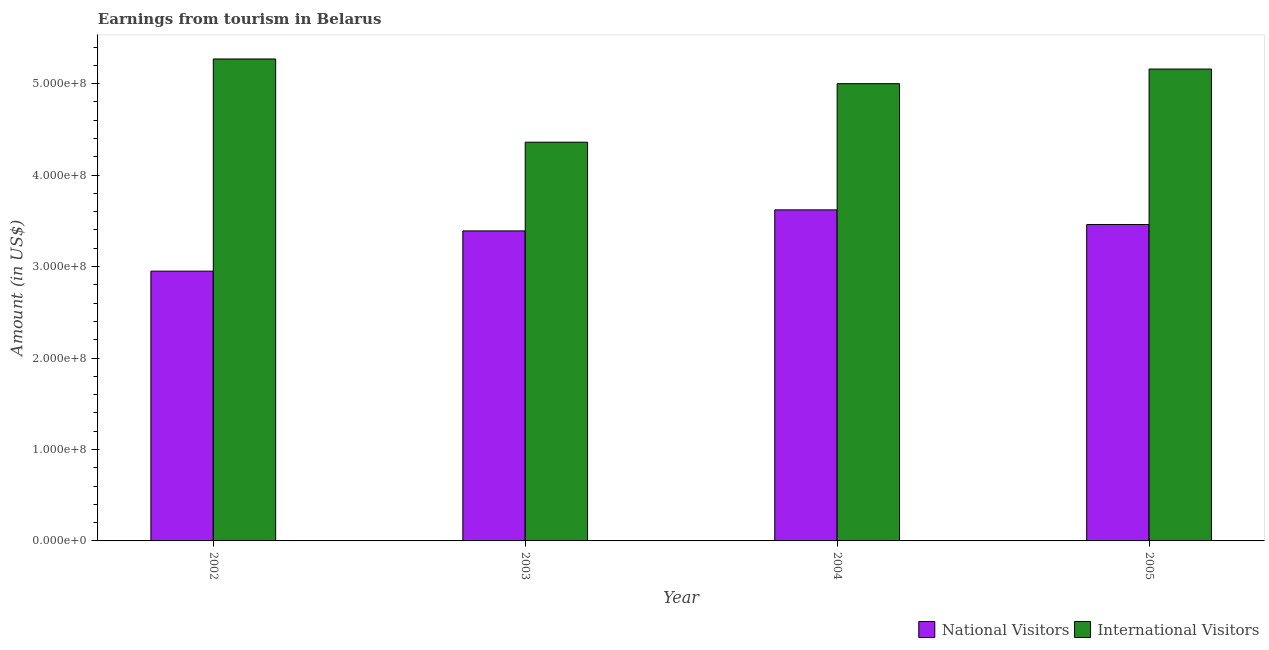Are the number of bars on each tick of the X-axis equal?
Your response must be concise. Yes. How many bars are there on the 4th tick from the left?
Ensure brevity in your answer.  2. What is the amount earned from international visitors in 2005?
Offer a very short reply. 5.16e+08. Across all years, what is the maximum amount earned from international visitors?
Ensure brevity in your answer.  5.27e+08. Across all years, what is the minimum amount earned from national visitors?
Make the answer very short. 2.95e+08. What is the total amount earned from international visitors in the graph?
Give a very brief answer. 1.98e+09. What is the difference between the amount earned from international visitors in 2002 and that in 2003?
Offer a terse response. 9.10e+07. What is the difference between the amount earned from national visitors in 2004 and the amount earned from international visitors in 2002?
Offer a terse response. 6.70e+07. What is the average amount earned from international visitors per year?
Keep it short and to the point. 4.95e+08. What is the ratio of the amount earned from international visitors in 2002 to that in 2004?
Offer a very short reply. 1.05. Is the difference between the amount earned from international visitors in 2002 and 2005 greater than the difference between the amount earned from national visitors in 2002 and 2005?
Make the answer very short. No. What is the difference between the highest and the second highest amount earned from national visitors?
Your answer should be very brief. 1.60e+07. What is the difference between the highest and the lowest amount earned from national visitors?
Offer a terse response. 6.70e+07. In how many years, is the amount earned from international visitors greater than the average amount earned from international visitors taken over all years?
Your answer should be very brief. 3. What does the 1st bar from the left in 2002 represents?
Give a very brief answer. National Visitors. What does the 1st bar from the right in 2002 represents?
Provide a succinct answer. International Visitors. How many years are there in the graph?
Ensure brevity in your answer.  4. Does the graph contain any zero values?
Give a very brief answer. No. Where does the legend appear in the graph?
Provide a short and direct response. Bottom right. What is the title of the graph?
Offer a very short reply. Earnings from tourism in Belarus. What is the label or title of the X-axis?
Make the answer very short. Year. What is the Amount (in US$) of National Visitors in 2002?
Offer a very short reply. 2.95e+08. What is the Amount (in US$) in International Visitors in 2002?
Keep it short and to the point. 5.27e+08. What is the Amount (in US$) in National Visitors in 2003?
Offer a terse response. 3.39e+08. What is the Amount (in US$) of International Visitors in 2003?
Give a very brief answer. 4.36e+08. What is the Amount (in US$) in National Visitors in 2004?
Offer a terse response. 3.62e+08. What is the Amount (in US$) in National Visitors in 2005?
Make the answer very short. 3.46e+08. What is the Amount (in US$) of International Visitors in 2005?
Make the answer very short. 5.16e+08. Across all years, what is the maximum Amount (in US$) of National Visitors?
Ensure brevity in your answer.  3.62e+08. Across all years, what is the maximum Amount (in US$) in International Visitors?
Your answer should be very brief. 5.27e+08. Across all years, what is the minimum Amount (in US$) of National Visitors?
Your answer should be compact. 2.95e+08. Across all years, what is the minimum Amount (in US$) in International Visitors?
Give a very brief answer. 4.36e+08. What is the total Amount (in US$) in National Visitors in the graph?
Give a very brief answer. 1.34e+09. What is the total Amount (in US$) of International Visitors in the graph?
Your answer should be compact. 1.98e+09. What is the difference between the Amount (in US$) in National Visitors in 2002 and that in 2003?
Offer a very short reply. -4.40e+07. What is the difference between the Amount (in US$) in International Visitors in 2002 and that in 2003?
Offer a very short reply. 9.10e+07. What is the difference between the Amount (in US$) of National Visitors in 2002 and that in 2004?
Give a very brief answer. -6.70e+07. What is the difference between the Amount (in US$) in International Visitors in 2002 and that in 2004?
Your answer should be very brief. 2.70e+07. What is the difference between the Amount (in US$) of National Visitors in 2002 and that in 2005?
Give a very brief answer. -5.10e+07. What is the difference between the Amount (in US$) of International Visitors in 2002 and that in 2005?
Make the answer very short. 1.10e+07. What is the difference between the Amount (in US$) in National Visitors in 2003 and that in 2004?
Provide a short and direct response. -2.30e+07. What is the difference between the Amount (in US$) in International Visitors in 2003 and that in 2004?
Ensure brevity in your answer.  -6.40e+07. What is the difference between the Amount (in US$) of National Visitors in 2003 and that in 2005?
Give a very brief answer. -7.00e+06. What is the difference between the Amount (in US$) in International Visitors in 2003 and that in 2005?
Offer a very short reply. -8.00e+07. What is the difference between the Amount (in US$) of National Visitors in 2004 and that in 2005?
Your response must be concise. 1.60e+07. What is the difference between the Amount (in US$) in International Visitors in 2004 and that in 2005?
Your response must be concise. -1.60e+07. What is the difference between the Amount (in US$) in National Visitors in 2002 and the Amount (in US$) in International Visitors in 2003?
Offer a very short reply. -1.41e+08. What is the difference between the Amount (in US$) in National Visitors in 2002 and the Amount (in US$) in International Visitors in 2004?
Ensure brevity in your answer.  -2.05e+08. What is the difference between the Amount (in US$) of National Visitors in 2002 and the Amount (in US$) of International Visitors in 2005?
Make the answer very short. -2.21e+08. What is the difference between the Amount (in US$) of National Visitors in 2003 and the Amount (in US$) of International Visitors in 2004?
Ensure brevity in your answer.  -1.61e+08. What is the difference between the Amount (in US$) of National Visitors in 2003 and the Amount (in US$) of International Visitors in 2005?
Keep it short and to the point. -1.77e+08. What is the difference between the Amount (in US$) in National Visitors in 2004 and the Amount (in US$) in International Visitors in 2005?
Offer a terse response. -1.54e+08. What is the average Amount (in US$) in National Visitors per year?
Your answer should be compact. 3.36e+08. What is the average Amount (in US$) of International Visitors per year?
Your answer should be very brief. 4.95e+08. In the year 2002, what is the difference between the Amount (in US$) in National Visitors and Amount (in US$) in International Visitors?
Give a very brief answer. -2.32e+08. In the year 2003, what is the difference between the Amount (in US$) of National Visitors and Amount (in US$) of International Visitors?
Ensure brevity in your answer.  -9.70e+07. In the year 2004, what is the difference between the Amount (in US$) of National Visitors and Amount (in US$) of International Visitors?
Ensure brevity in your answer.  -1.38e+08. In the year 2005, what is the difference between the Amount (in US$) of National Visitors and Amount (in US$) of International Visitors?
Your response must be concise. -1.70e+08. What is the ratio of the Amount (in US$) of National Visitors in 2002 to that in 2003?
Your response must be concise. 0.87. What is the ratio of the Amount (in US$) in International Visitors in 2002 to that in 2003?
Make the answer very short. 1.21. What is the ratio of the Amount (in US$) in National Visitors in 2002 to that in 2004?
Offer a terse response. 0.81. What is the ratio of the Amount (in US$) in International Visitors in 2002 to that in 2004?
Ensure brevity in your answer.  1.05. What is the ratio of the Amount (in US$) of National Visitors in 2002 to that in 2005?
Ensure brevity in your answer.  0.85. What is the ratio of the Amount (in US$) of International Visitors in 2002 to that in 2005?
Offer a very short reply. 1.02. What is the ratio of the Amount (in US$) in National Visitors in 2003 to that in 2004?
Offer a very short reply. 0.94. What is the ratio of the Amount (in US$) of International Visitors in 2003 to that in 2004?
Give a very brief answer. 0.87. What is the ratio of the Amount (in US$) of National Visitors in 2003 to that in 2005?
Keep it short and to the point. 0.98. What is the ratio of the Amount (in US$) of International Visitors in 2003 to that in 2005?
Your response must be concise. 0.84. What is the ratio of the Amount (in US$) of National Visitors in 2004 to that in 2005?
Keep it short and to the point. 1.05. What is the ratio of the Amount (in US$) of International Visitors in 2004 to that in 2005?
Offer a terse response. 0.97. What is the difference between the highest and the second highest Amount (in US$) of National Visitors?
Provide a short and direct response. 1.60e+07. What is the difference between the highest and the second highest Amount (in US$) of International Visitors?
Offer a very short reply. 1.10e+07. What is the difference between the highest and the lowest Amount (in US$) in National Visitors?
Ensure brevity in your answer.  6.70e+07. What is the difference between the highest and the lowest Amount (in US$) of International Visitors?
Your answer should be compact. 9.10e+07. 